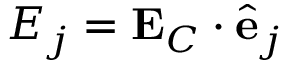<formula> <loc_0><loc_0><loc_500><loc_500>E _ { j } = E _ { C } \cdot \hat { e } _ { j }</formula> 